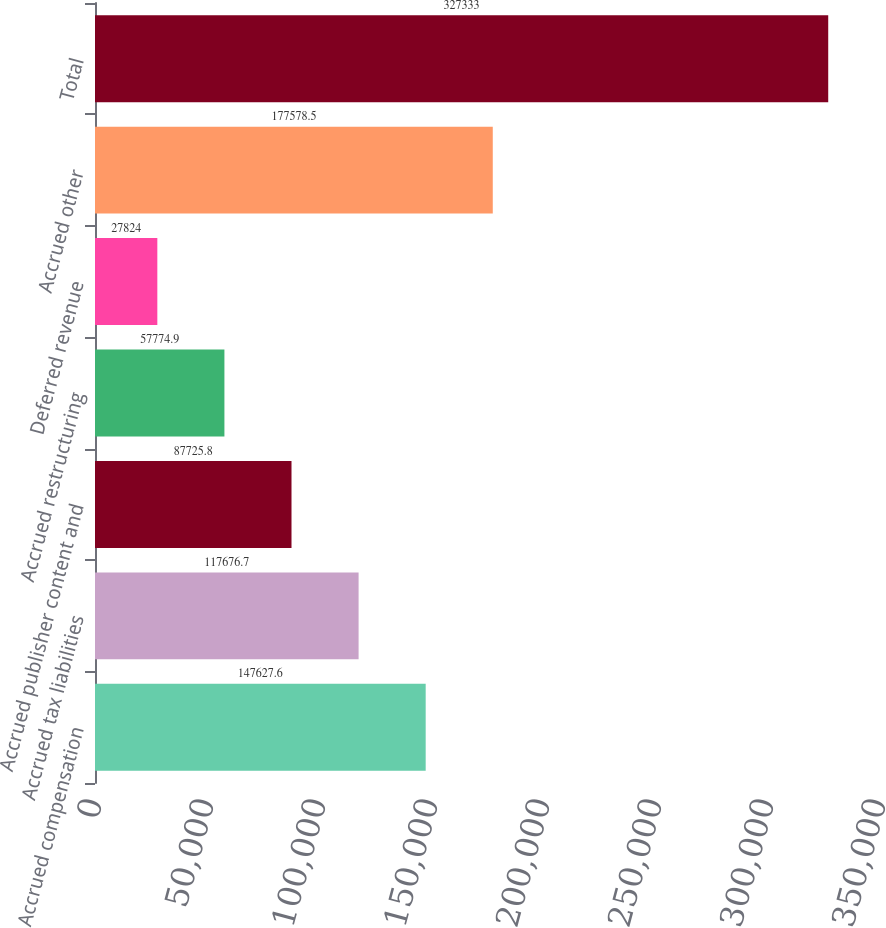<chart> <loc_0><loc_0><loc_500><loc_500><bar_chart><fcel>Accrued compensation<fcel>Accrued tax liabilities<fcel>Accrued publisher content and<fcel>Accrued restructuring<fcel>Deferred revenue<fcel>Accrued other<fcel>Total<nl><fcel>147628<fcel>117677<fcel>87725.8<fcel>57774.9<fcel>27824<fcel>177578<fcel>327333<nl></chart> 